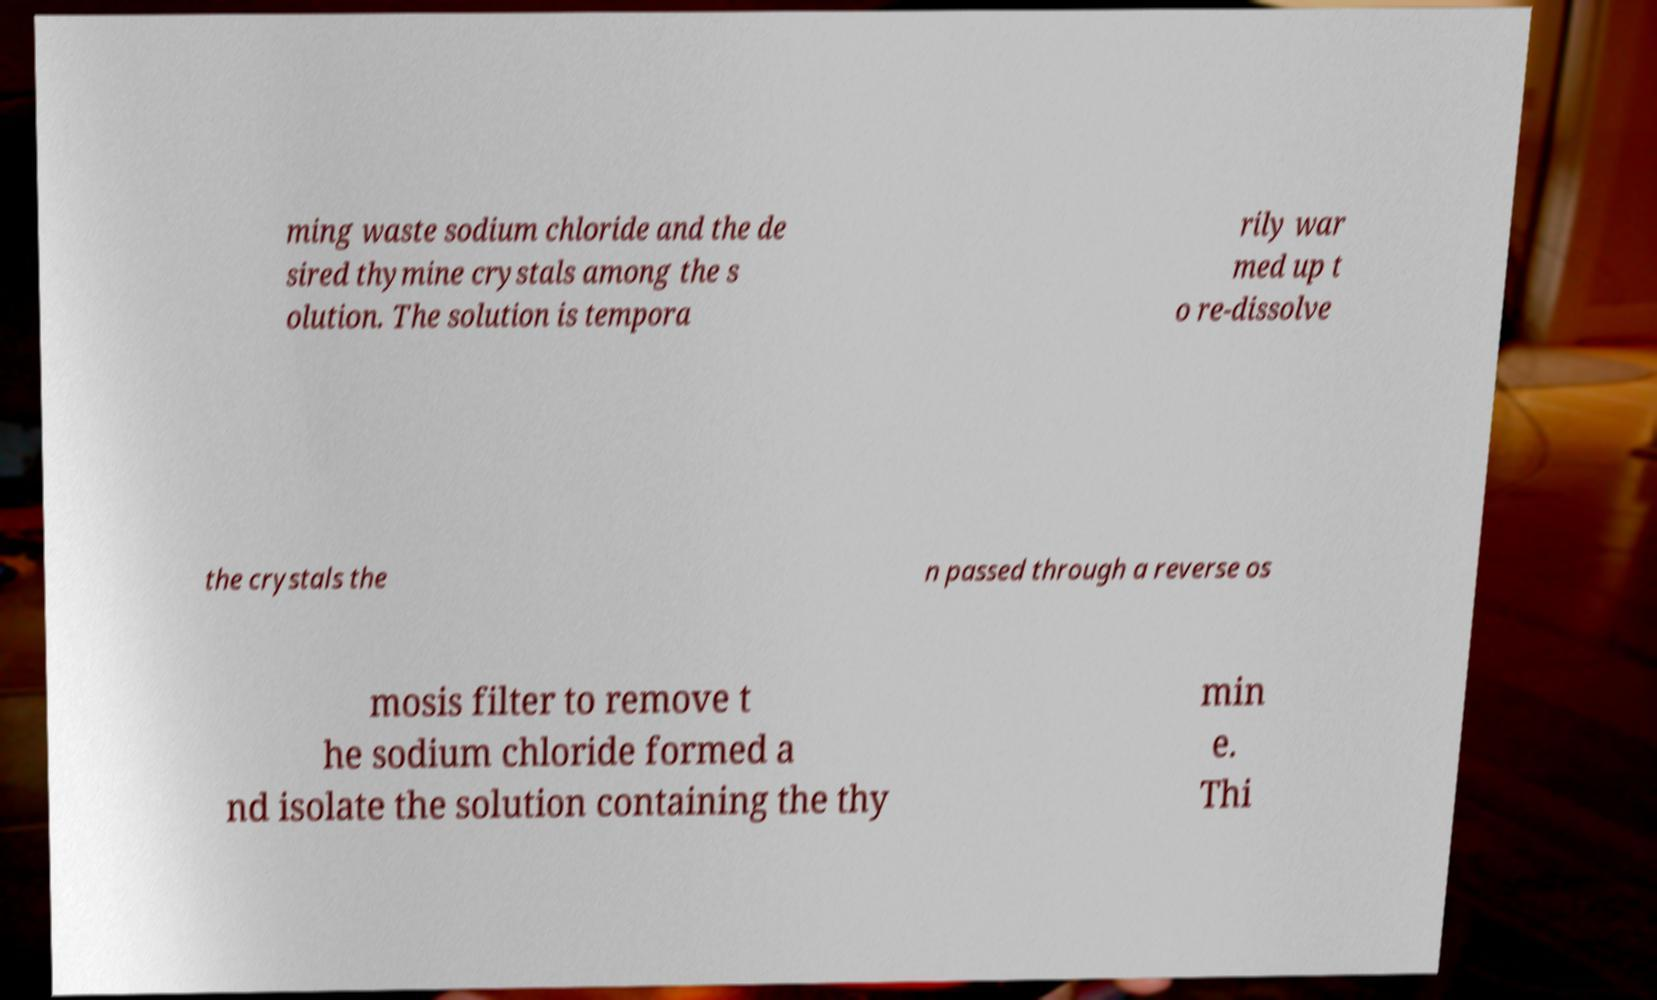Could you assist in decoding the text presented in this image and type it out clearly? ming waste sodium chloride and the de sired thymine crystals among the s olution. The solution is tempora rily war med up t o re-dissolve the crystals the n passed through a reverse os mosis filter to remove t he sodium chloride formed a nd isolate the solution containing the thy min e. Thi 